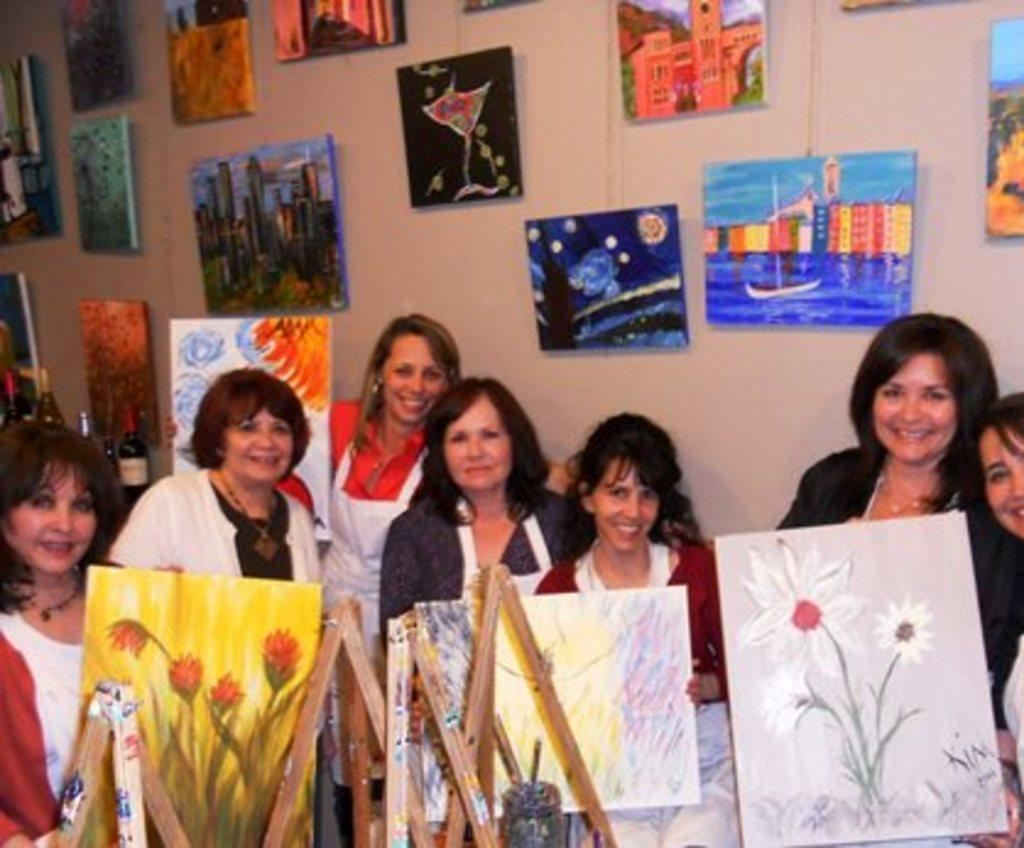What is the main subject of the image? The main subject of the image is a group of women. What are the women holding in the image? The women are holding paintings. What can be seen in the background of the image? There are paintings and a wall in the background of the image. Where is the cannon located in the image? There is no cannon present in the image. What type of home is depicted in the image? The image does not depict a home; it features a group of women holding paintings. 